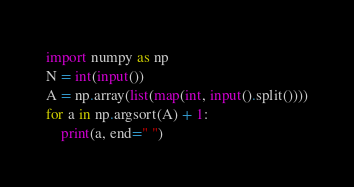Convert code to text. <code><loc_0><loc_0><loc_500><loc_500><_Python_>import numpy as np
N = int(input())
A = np.array(list(map(int, input().split())))
for a in np.argsort(A) + 1:
    print(a, end=" ")</code> 